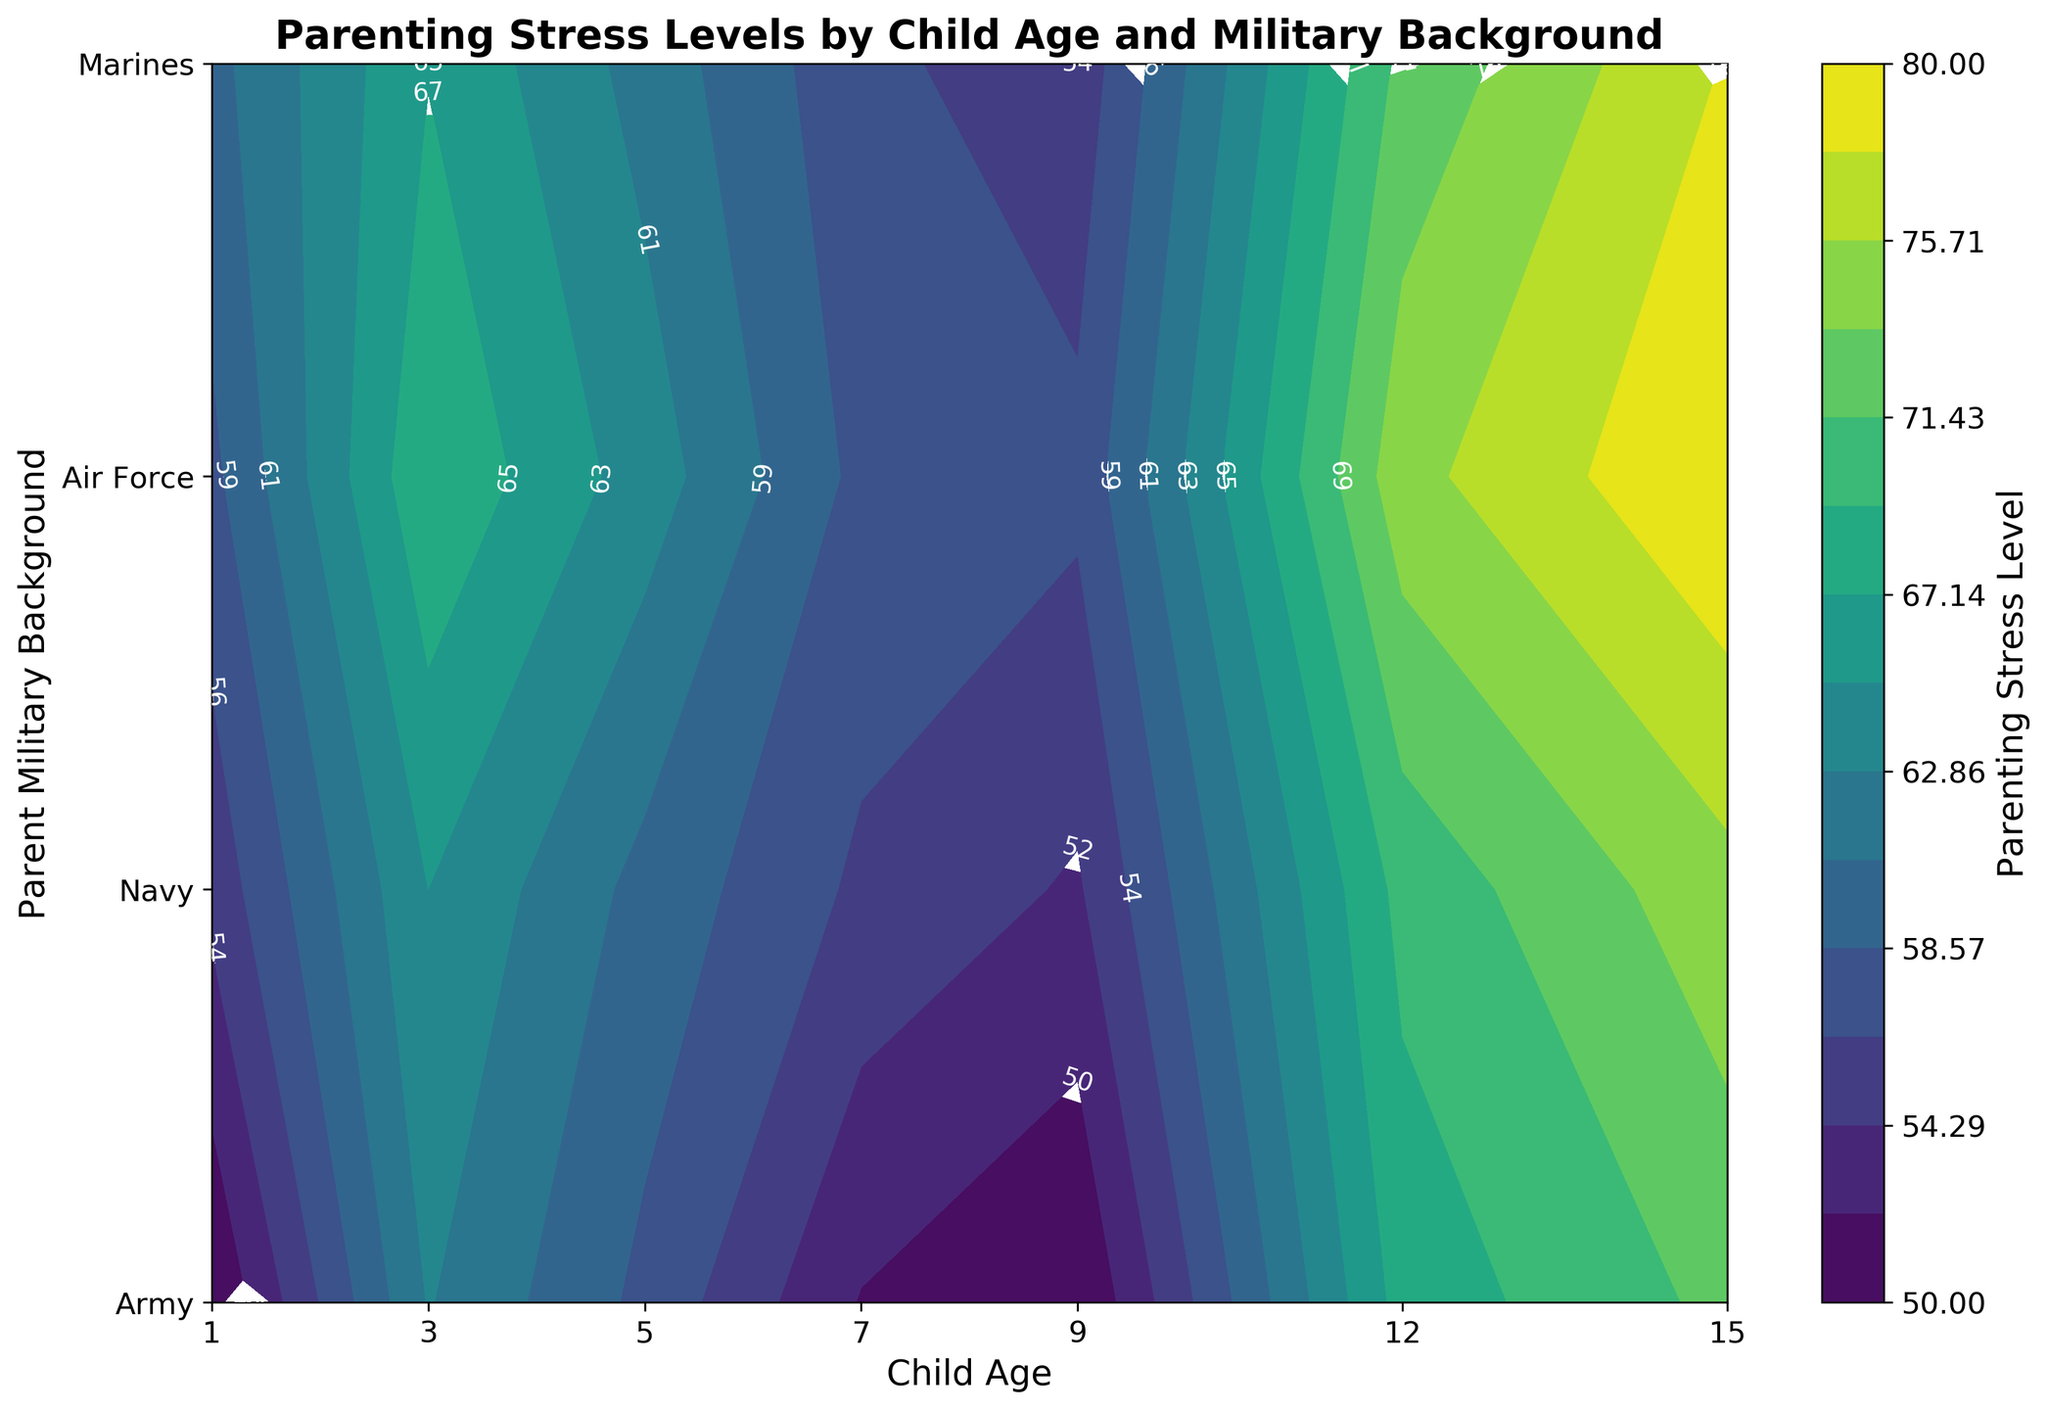What is the title of the contour plot? The title is generally located at the top of the plot and is used to describe the content of the figure. In this plot, the title is "Parenting Stress Levels by Child Age and Military Background."
Answer: Parenting Stress Levels by Child Age and Military Background At what child age does the Army parent's stress level reach the highest value? Looking at the contour plot, you can identify the specific levels of stress corresponding to various ages and military backgrounds. For the Army, the highest stress level is at age 15.
Answer: 15 What is the minimum parenting stress level recorded for Air Force parents across all child ages? The contour plot will display areas of low stress levels in lighter colors. By examining these areas, we find that the minimum stress level recorded for Air Force parents is 50, which appears at child ages 1 and 9.
Answer: 50 Which military background has the highest parenting stress level at child age 3? By looking at the contour lines and colors representing higher stress levels at child age 3, you can see that the Marines have the highest stress level, which is 69.
Answer: Marines Compare the parenting stress levels between Marines and Navy at child age 7. Which is higher? Locate child age 7 on the x-axis and trace vertically to compare the stress levels for Marines and Navy. The stress levels are 58 for Marines and 57 for Navy, hence the Marines have a higher stress level.
Answer: Marines What is the average parenting stress level for Army parents across all child ages? To find the average, sum the stress levels for Army parents across all ages (55 + 65 + 60 + 56 + 54 + 70 + 75) which equals 435, then divide by the number of data points (7). The average is 435 / 7.
Answer: 62.14 Which military background shows the most significant increase in parenting stress level as the child ages from 1 to 15? By examining the change in stress levels from age 1 to 15 for all military backgrounds, you can see the stress levels for Marines go from 58 to 80, a difference of 22 units. This is the largest increase compared to other backgrounds.
Answer: Marines How does the parenting stress level for Navy parents change from child age 1 to age 12? First, note the stress levels at ages 1 and 12 for Navy parents which are 60 and 72 respectively. The change in stress level is 72 - 60 = 12 units.
Answer: Increases by 12 units At child age 5, which military background has the lowest parenting stress level? Refer to the contour plot and find the stress levels for all military backgrounds at age 5. The values are 60 (Army), 62 (Navy), 58 (Air Force), and 64 (Marines). The Air Force has the lowest stress level of 58.
Answer: Air Force What is the contour line label color in the plot? The labels on the contour lines, which provide the numeric values, are shown in white for better visibility against the background colors.
Answer: White 